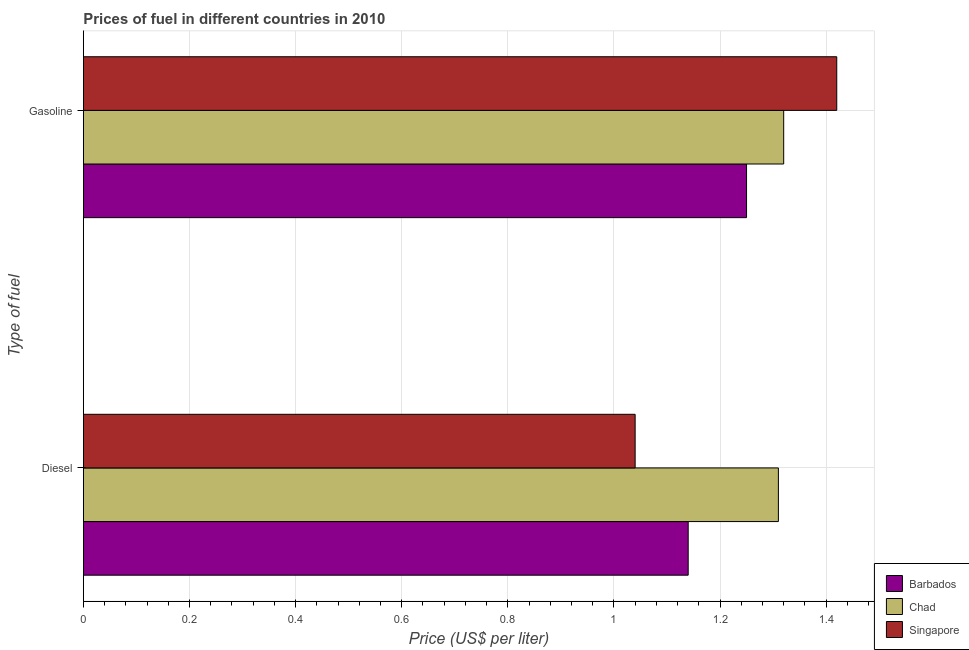How many different coloured bars are there?
Offer a very short reply. 3. How many groups of bars are there?
Provide a succinct answer. 2. Are the number of bars on each tick of the Y-axis equal?
Give a very brief answer. Yes. How many bars are there on the 2nd tick from the bottom?
Make the answer very short. 3. What is the label of the 1st group of bars from the top?
Ensure brevity in your answer.  Gasoline. What is the gasoline price in Singapore?
Your answer should be very brief. 1.42. Across all countries, what is the maximum diesel price?
Your response must be concise. 1.31. Across all countries, what is the minimum diesel price?
Your answer should be compact. 1.04. In which country was the gasoline price maximum?
Keep it short and to the point. Singapore. In which country was the gasoline price minimum?
Offer a terse response. Barbados. What is the total gasoline price in the graph?
Offer a very short reply. 3.99. What is the difference between the gasoline price in Barbados and that in Chad?
Your answer should be very brief. -0.07. What is the difference between the diesel price in Chad and the gasoline price in Singapore?
Your answer should be compact. -0.11. What is the average gasoline price per country?
Offer a very short reply. 1.33. What is the difference between the gasoline price and diesel price in Barbados?
Your answer should be compact. 0.11. In how many countries, is the diesel price greater than 0.8400000000000001 US$ per litre?
Provide a succinct answer. 3. What is the ratio of the gasoline price in Singapore to that in Barbados?
Make the answer very short. 1.14. Is the diesel price in Barbados less than that in Chad?
Your answer should be very brief. Yes. What does the 3rd bar from the top in Gasoline represents?
Give a very brief answer. Barbados. What does the 1st bar from the bottom in Diesel represents?
Offer a terse response. Barbados. What is the difference between two consecutive major ticks on the X-axis?
Your answer should be very brief. 0.2. How many legend labels are there?
Your answer should be very brief. 3. How are the legend labels stacked?
Ensure brevity in your answer.  Vertical. What is the title of the graph?
Offer a terse response. Prices of fuel in different countries in 2010. Does "Iceland" appear as one of the legend labels in the graph?
Keep it short and to the point. No. What is the label or title of the X-axis?
Keep it short and to the point. Price (US$ per liter). What is the label or title of the Y-axis?
Ensure brevity in your answer.  Type of fuel. What is the Price (US$ per liter) in Barbados in Diesel?
Your answer should be compact. 1.14. What is the Price (US$ per liter) in Chad in Diesel?
Keep it short and to the point. 1.31. What is the Price (US$ per liter) in Chad in Gasoline?
Keep it short and to the point. 1.32. What is the Price (US$ per liter) in Singapore in Gasoline?
Your answer should be compact. 1.42. Across all Type of fuel, what is the maximum Price (US$ per liter) in Chad?
Keep it short and to the point. 1.32. Across all Type of fuel, what is the maximum Price (US$ per liter) of Singapore?
Ensure brevity in your answer.  1.42. Across all Type of fuel, what is the minimum Price (US$ per liter) of Barbados?
Make the answer very short. 1.14. Across all Type of fuel, what is the minimum Price (US$ per liter) in Chad?
Give a very brief answer. 1.31. Across all Type of fuel, what is the minimum Price (US$ per liter) in Singapore?
Ensure brevity in your answer.  1.04. What is the total Price (US$ per liter) of Barbados in the graph?
Keep it short and to the point. 2.39. What is the total Price (US$ per liter) in Chad in the graph?
Make the answer very short. 2.63. What is the total Price (US$ per liter) of Singapore in the graph?
Make the answer very short. 2.46. What is the difference between the Price (US$ per liter) in Barbados in Diesel and that in Gasoline?
Ensure brevity in your answer.  -0.11. What is the difference between the Price (US$ per liter) in Chad in Diesel and that in Gasoline?
Your answer should be very brief. -0.01. What is the difference between the Price (US$ per liter) in Singapore in Diesel and that in Gasoline?
Provide a short and direct response. -0.38. What is the difference between the Price (US$ per liter) of Barbados in Diesel and the Price (US$ per liter) of Chad in Gasoline?
Offer a terse response. -0.18. What is the difference between the Price (US$ per liter) of Barbados in Diesel and the Price (US$ per liter) of Singapore in Gasoline?
Give a very brief answer. -0.28. What is the difference between the Price (US$ per liter) in Chad in Diesel and the Price (US$ per liter) in Singapore in Gasoline?
Ensure brevity in your answer.  -0.11. What is the average Price (US$ per liter) in Barbados per Type of fuel?
Keep it short and to the point. 1.2. What is the average Price (US$ per liter) in Chad per Type of fuel?
Ensure brevity in your answer.  1.31. What is the average Price (US$ per liter) of Singapore per Type of fuel?
Give a very brief answer. 1.23. What is the difference between the Price (US$ per liter) of Barbados and Price (US$ per liter) of Chad in Diesel?
Provide a succinct answer. -0.17. What is the difference between the Price (US$ per liter) in Barbados and Price (US$ per liter) in Singapore in Diesel?
Your answer should be compact. 0.1. What is the difference between the Price (US$ per liter) of Chad and Price (US$ per liter) of Singapore in Diesel?
Ensure brevity in your answer.  0.27. What is the difference between the Price (US$ per liter) of Barbados and Price (US$ per liter) of Chad in Gasoline?
Ensure brevity in your answer.  -0.07. What is the difference between the Price (US$ per liter) of Barbados and Price (US$ per liter) of Singapore in Gasoline?
Give a very brief answer. -0.17. What is the ratio of the Price (US$ per liter) in Barbados in Diesel to that in Gasoline?
Offer a very short reply. 0.91. What is the ratio of the Price (US$ per liter) in Singapore in Diesel to that in Gasoline?
Keep it short and to the point. 0.73. What is the difference between the highest and the second highest Price (US$ per liter) in Barbados?
Keep it short and to the point. 0.11. What is the difference between the highest and the second highest Price (US$ per liter) in Singapore?
Give a very brief answer. 0.38. What is the difference between the highest and the lowest Price (US$ per liter) in Barbados?
Provide a short and direct response. 0.11. What is the difference between the highest and the lowest Price (US$ per liter) in Chad?
Ensure brevity in your answer.  0.01. What is the difference between the highest and the lowest Price (US$ per liter) of Singapore?
Ensure brevity in your answer.  0.38. 